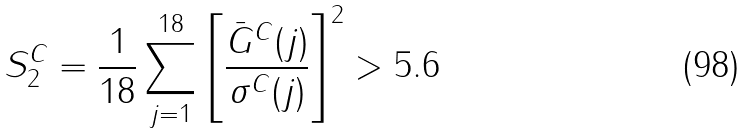<formula> <loc_0><loc_0><loc_500><loc_500>S _ { 2 } ^ { C } = \frac { 1 } { 1 8 } \sum _ { j = 1 } ^ { 1 8 } \left [ { \frac { \bar { G } ^ { C } ( j ) } { \sigma ^ { C } ( j ) } } \right ] ^ { 2 } > 5 . 6</formula> 